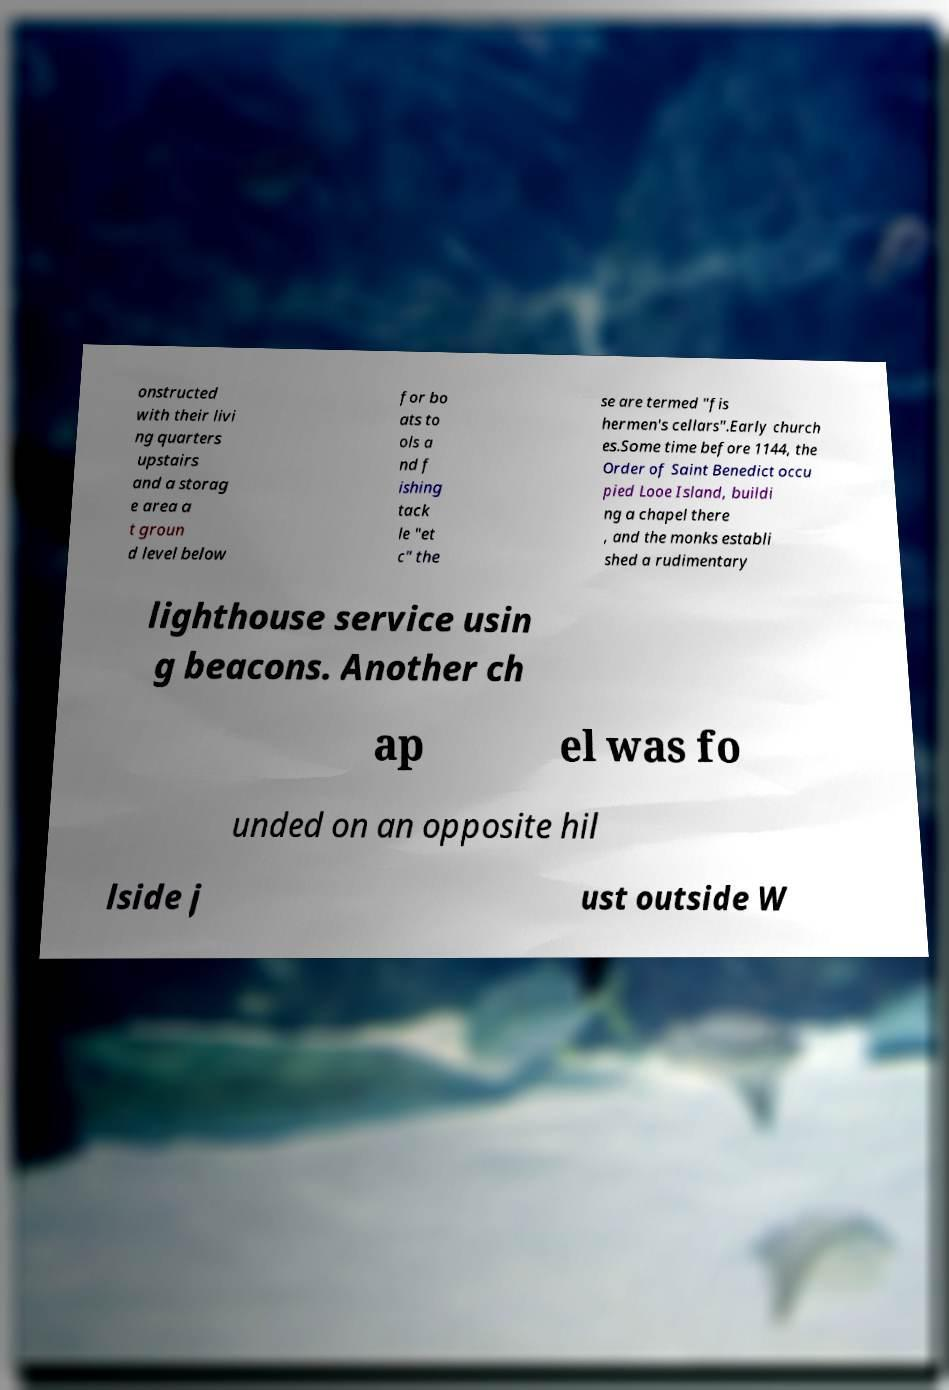Could you assist in decoding the text presented in this image and type it out clearly? onstructed with their livi ng quarters upstairs and a storag e area a t groun d level below for bo ats to ols a nd f ishing tack le "et c" the se are termed "fis hermen's cellars".Early church es.Some time before 1144, the Order of Saint Benedict occu pied Looe Island, buildi ng a chapel there , and the monks establi shed a rudimentary lighthouse service usin g beacons. Another ch ap el was fo unded on an opposite hil lside j ust outside W 